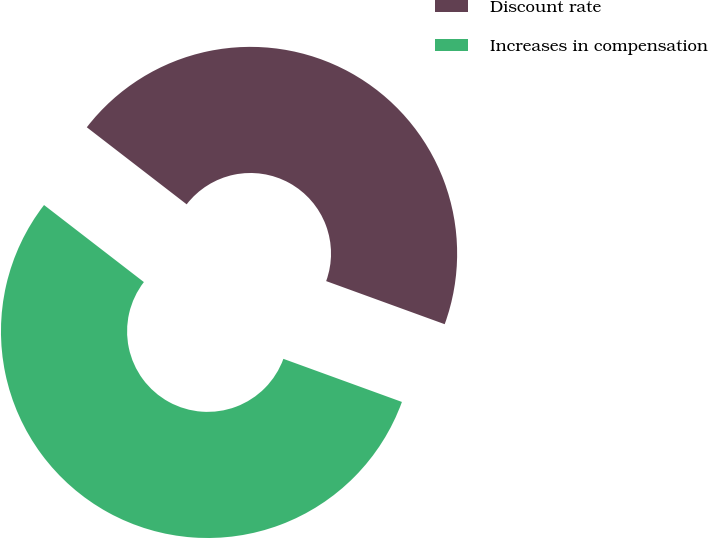Convert chart to OTSL. <chart><loc_0><loc_0><loc_500><loc_500><pie_chart><fcel>Discount rate<fcel>Increases in compensation<nl><fcel>45.09%<fcel>54.91%<nl></chart> 